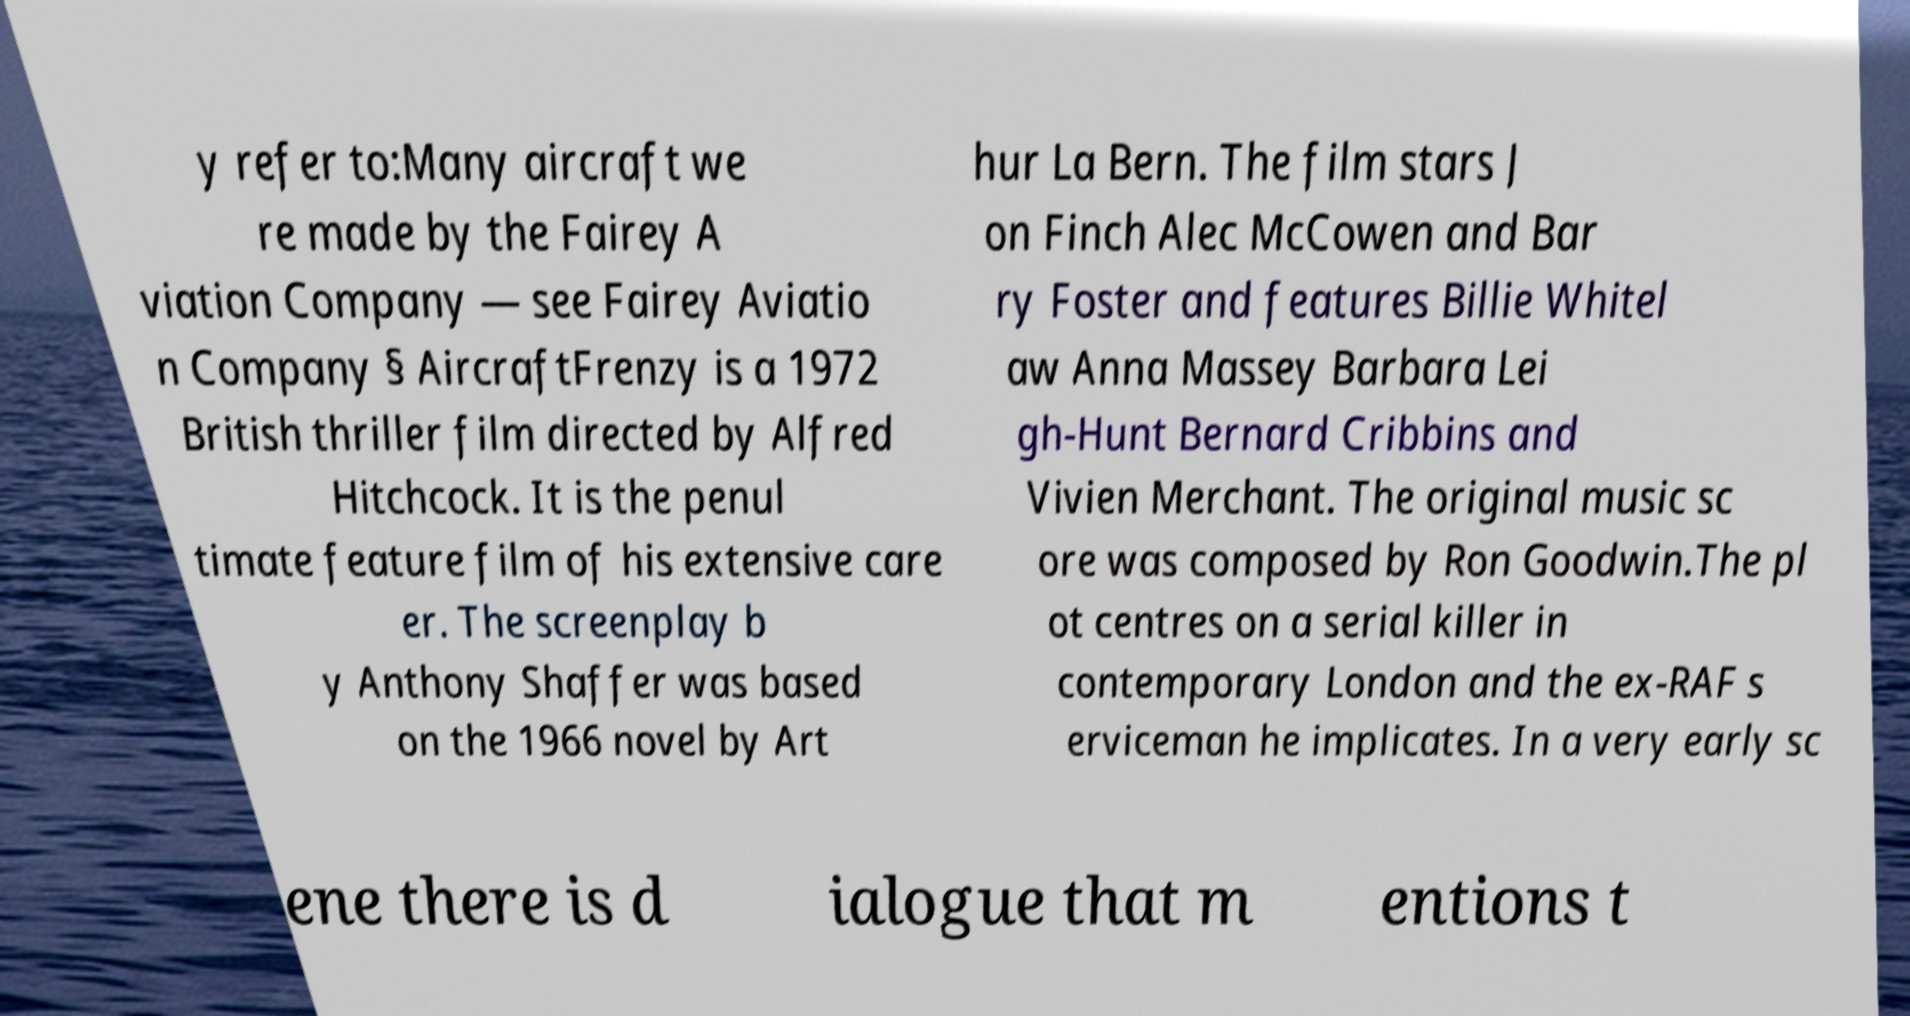Please read and relay the text visible in this image. What does it say? y refer to:Many aircraft we re made by the Fairey A viation Company — see Fairey Aviatio n Company § AircraftFrenzy is a 1972 British thriller film directed by Alfred Hitchcock. It is the penul timate feature film of his extensive care er. The screenplay b y Anthony Shaffer was based on the 1966 novel by Art hur La Bern. The film stars J on Finch Alec McCowen and Bar ry Foster and features Billie Whitel aw Anna Massey Barbara Lei gh-Hunt Bernard Cribbins and Vivien Merchant. The original music sc ore was composed by Ron Goodwin.The pl ot centres on a serial killer in contemporary London and the ex-RAF s erviceman he implicates. In a very early sc ene there is d ialogue that m entions t 